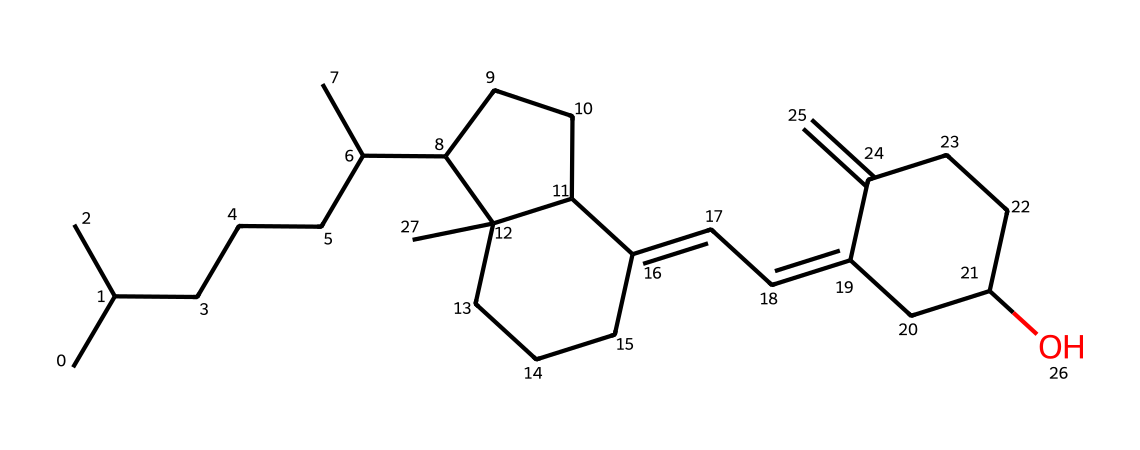What is the primary functional group present in vitamin D? The structure contains multiple rings and a hydroxyl group (-OH), indicating that the primary functional group is alcohol.
Answer: alcohol How many carbon atoms are in the structure? By counting the carbon atoms in the SMILES representation, we find there are 27 carbon atoms present.
Answer: 27 What type of vitamin is represented by this structure? Given the structure and functional groups, this compound can be classified as a fat-soluble vitamin, specifically vitamin D.
Answer: vitamin D How many double bonds are found in the chemical structure? Scanning through the structure, we identify 5 double bonds present in various parts of the rings and chain, contributing to the unsaturation.
Answer: 5 What is the main role of vitamin D in the human body? Vitamin D is primarily responsible for calcium absorption in the gut, which is essential for maintaining bone health and density.
Answer: calcium absorption Which part of this molecule is related to its biological activity? The hydroxyl group (-OH) attached to the carbon skeleton plays a key role in the biological activity by enabling interactions with receptors in the body.
Answer: hydroxyl group 